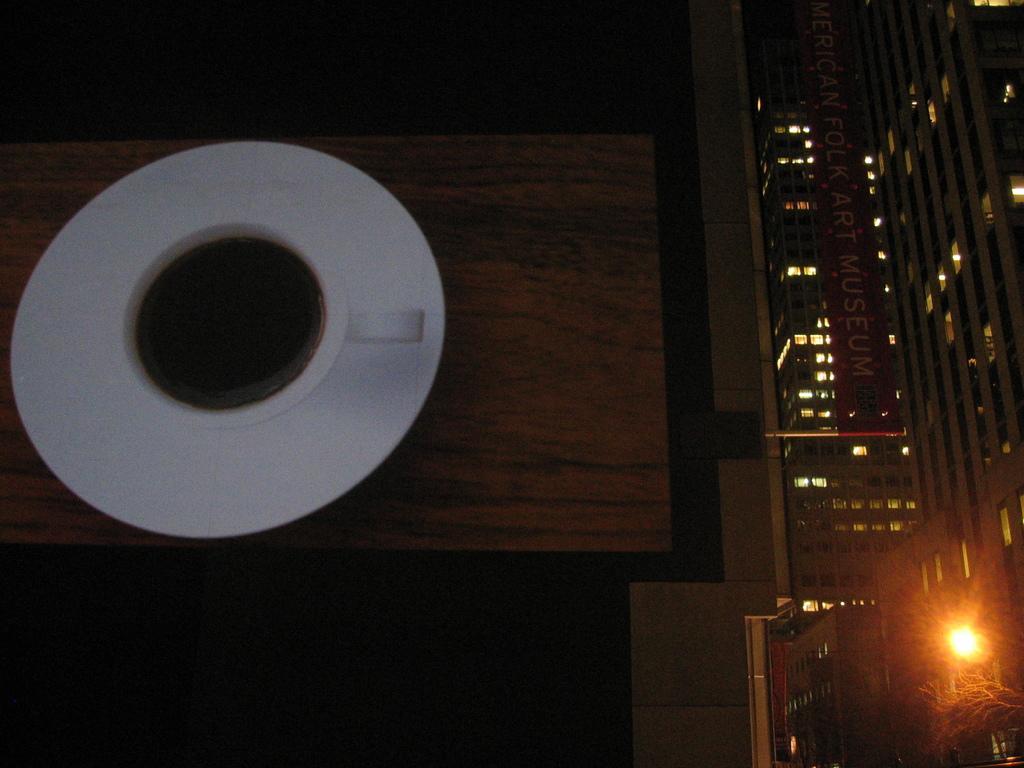In one or two sentences, can you explain what this image depicts? In this picture I can observe a cup and saucer on the left side. On the right side there are some buildings and yellow color light on the bottom right side. 